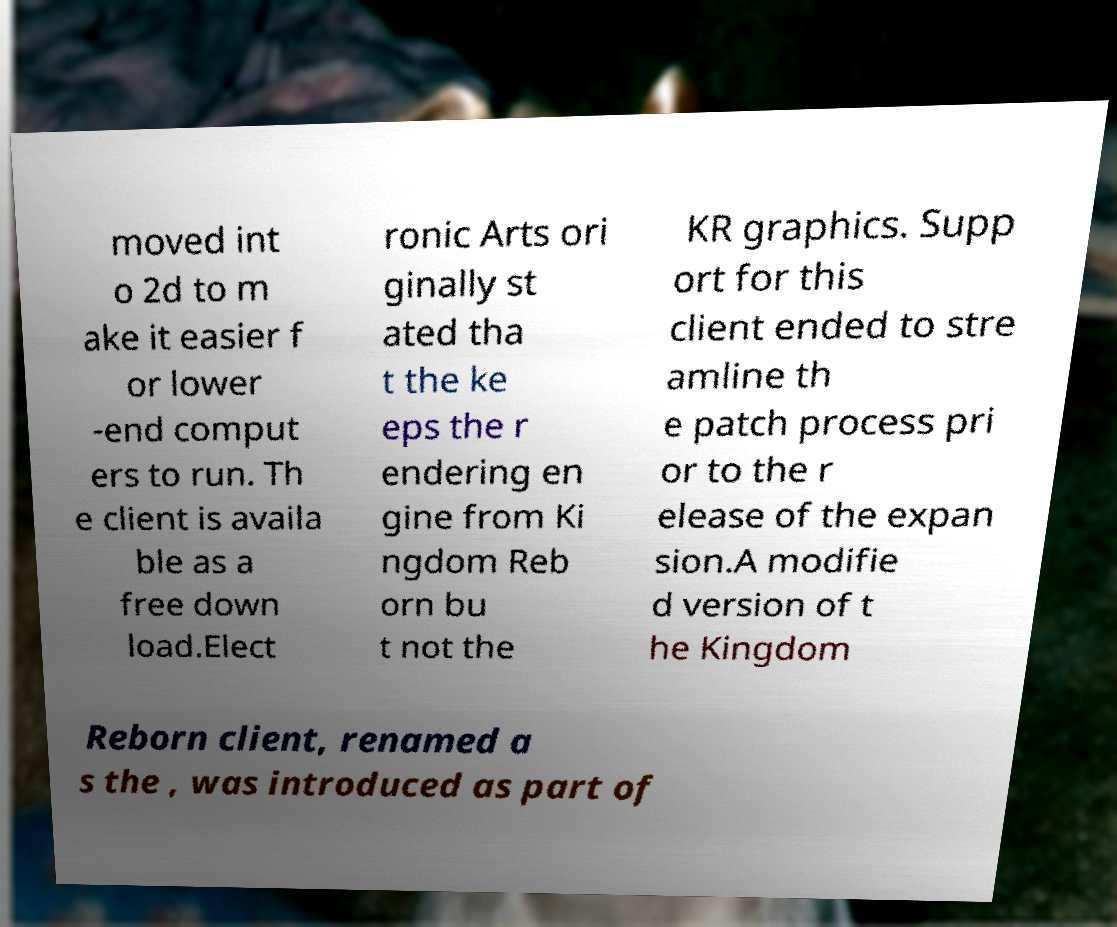Please read and relay the text visible in this image. What does it say? moved int o 2d to m ake it easier f or lower -end comput ers to run. Th e client is availa ble as a free down load.Elect ronic Arts ori ginally st ated tha t the ke eps the r endering en gine from Ki ngdom Reb orn bu t not the KR graphics. Supp ort for this client ended to stre amline th e patch process pri or to the r elease of the expan sion.A modifie d version of t he Kingdom Reborn client, renamed a s the , was introduced as part of 